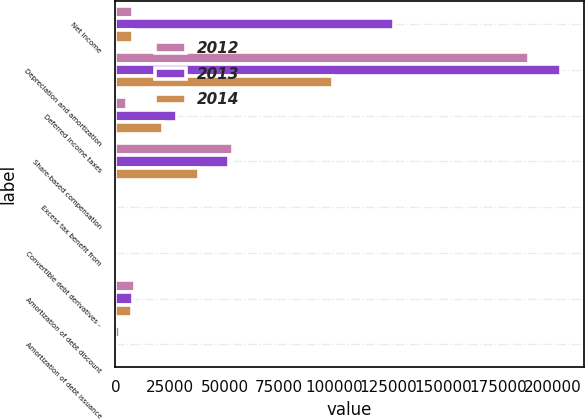<chart> <loc_0><loc_0><loc_500><loc_500><stacked_bar_chart><ecel><fcel>Net income<fcel>Depreciation and amortization<fcel>Deferred income taxes<fcel>Share-based compensation<fcel>Excess tax benefit from<fcel>Convertible debt derivatives -<fcel>Amortization of debt discount<fcel>Amortization of debt issuance<nl><fcel>2012<fcel>7854.5<fcel>189139<fcel>5321<fcel>53787<fcel>1411<fcel>482<fcel>8970<fcel>1959<nl><fcel>2013<fcel>127389<fcel>204097<fcel>28368<fcel>52069<fcel>297<fcel>138<fcel>8197<fcel>217<nl><fcel>2014<fcel>7854.5<fcel>99424<fcel>21954<fcel>38289<fcel>576<fcel>204<fcel>7512<fcel>219<nl></chart> 